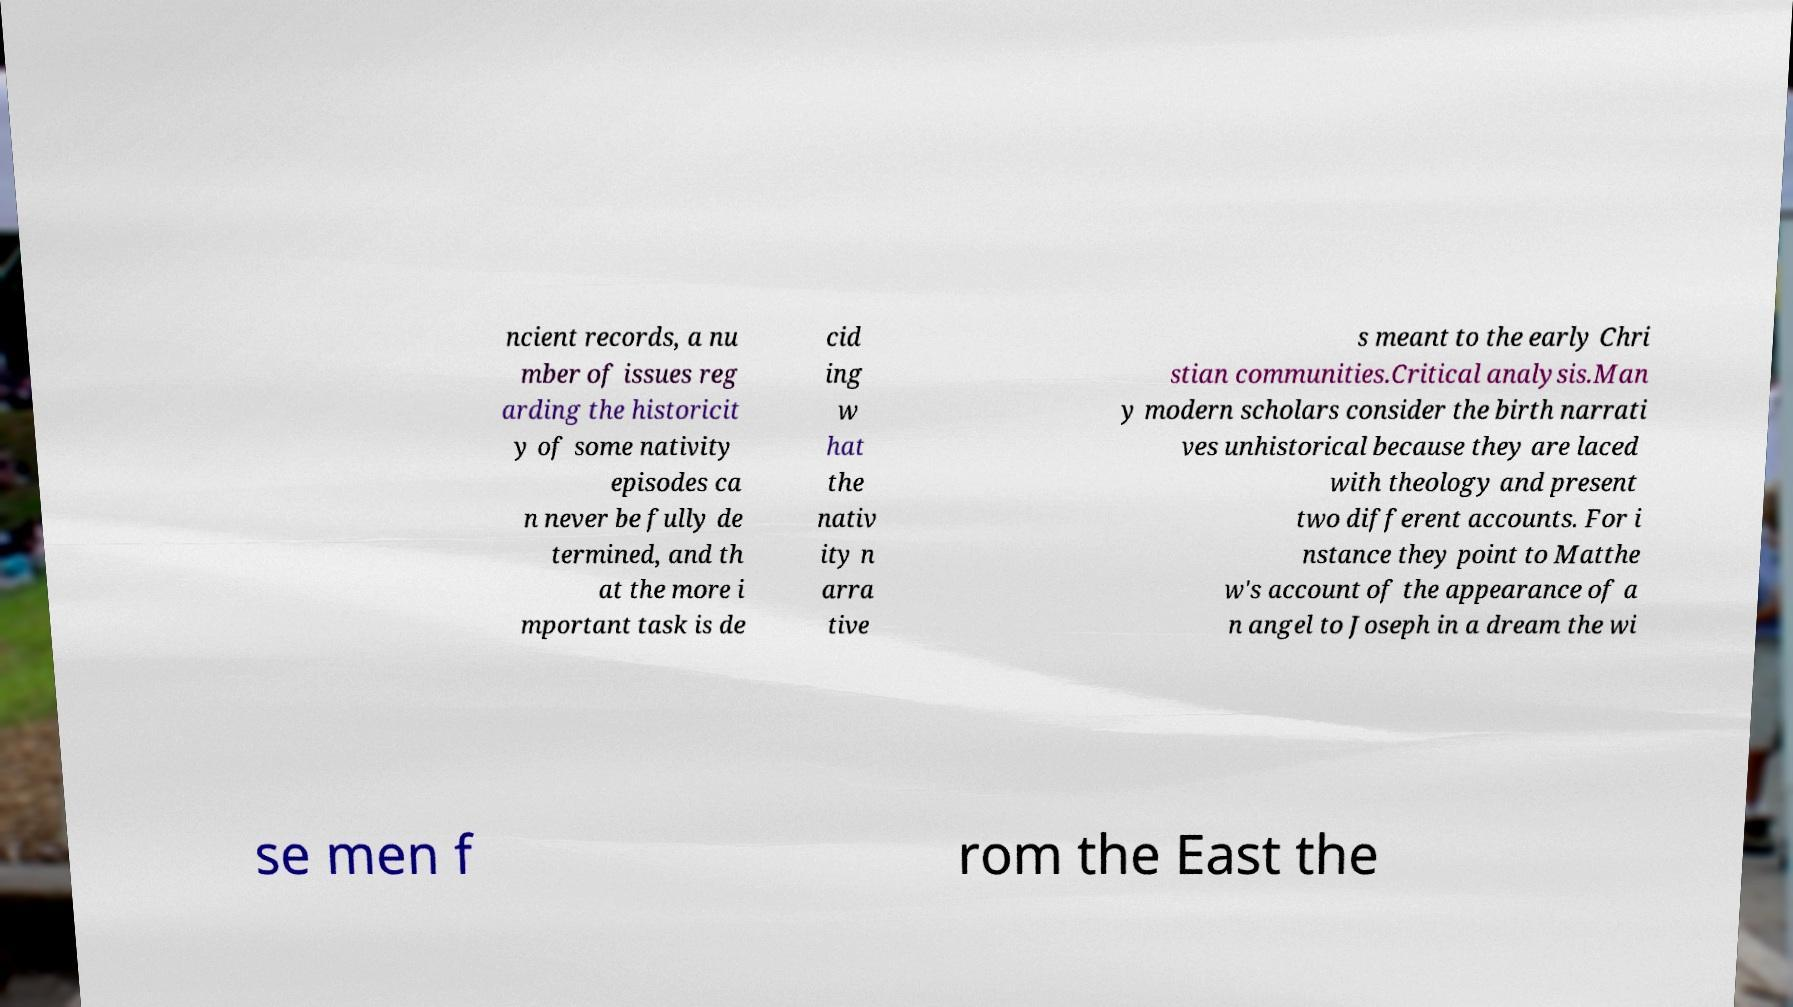What messages or text are displayed in this image? I need them in a readable, typed format. ncient records, a nu mber of issues reg arding the historicit y of some nativity episodes ca n never be fully de termined, and th at the more i mportant task is de cid ing w hat the nativ ity n arra tive s meant to the early Chri stian communities.Critical analysis.Man y modern scholars consider the birth narrati ves unhistorical because they are laced with theology and present two different accounts. For i nstance they point to Matthe w's account of the appearance of a n angel to Joseph in a dream the wi se men f rom the East the 